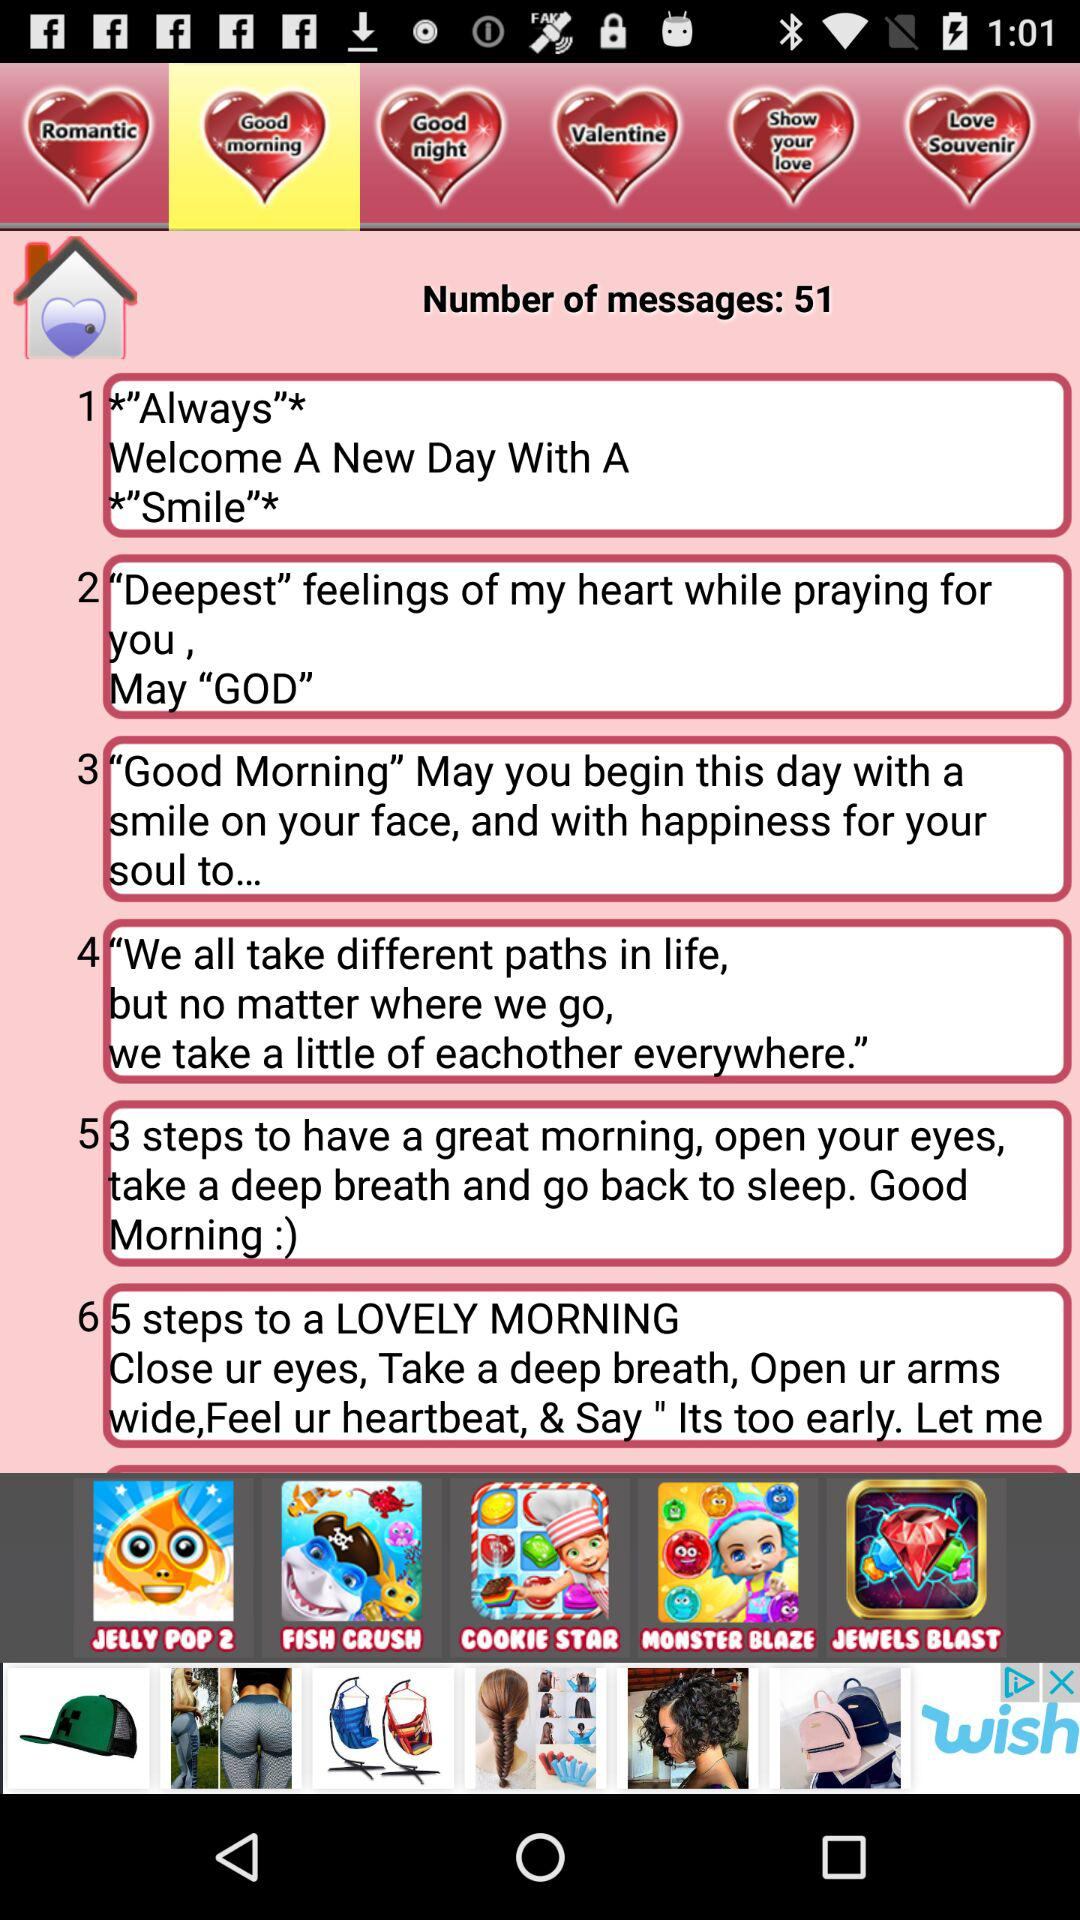What is the number of messages? The number of messages is 51. 